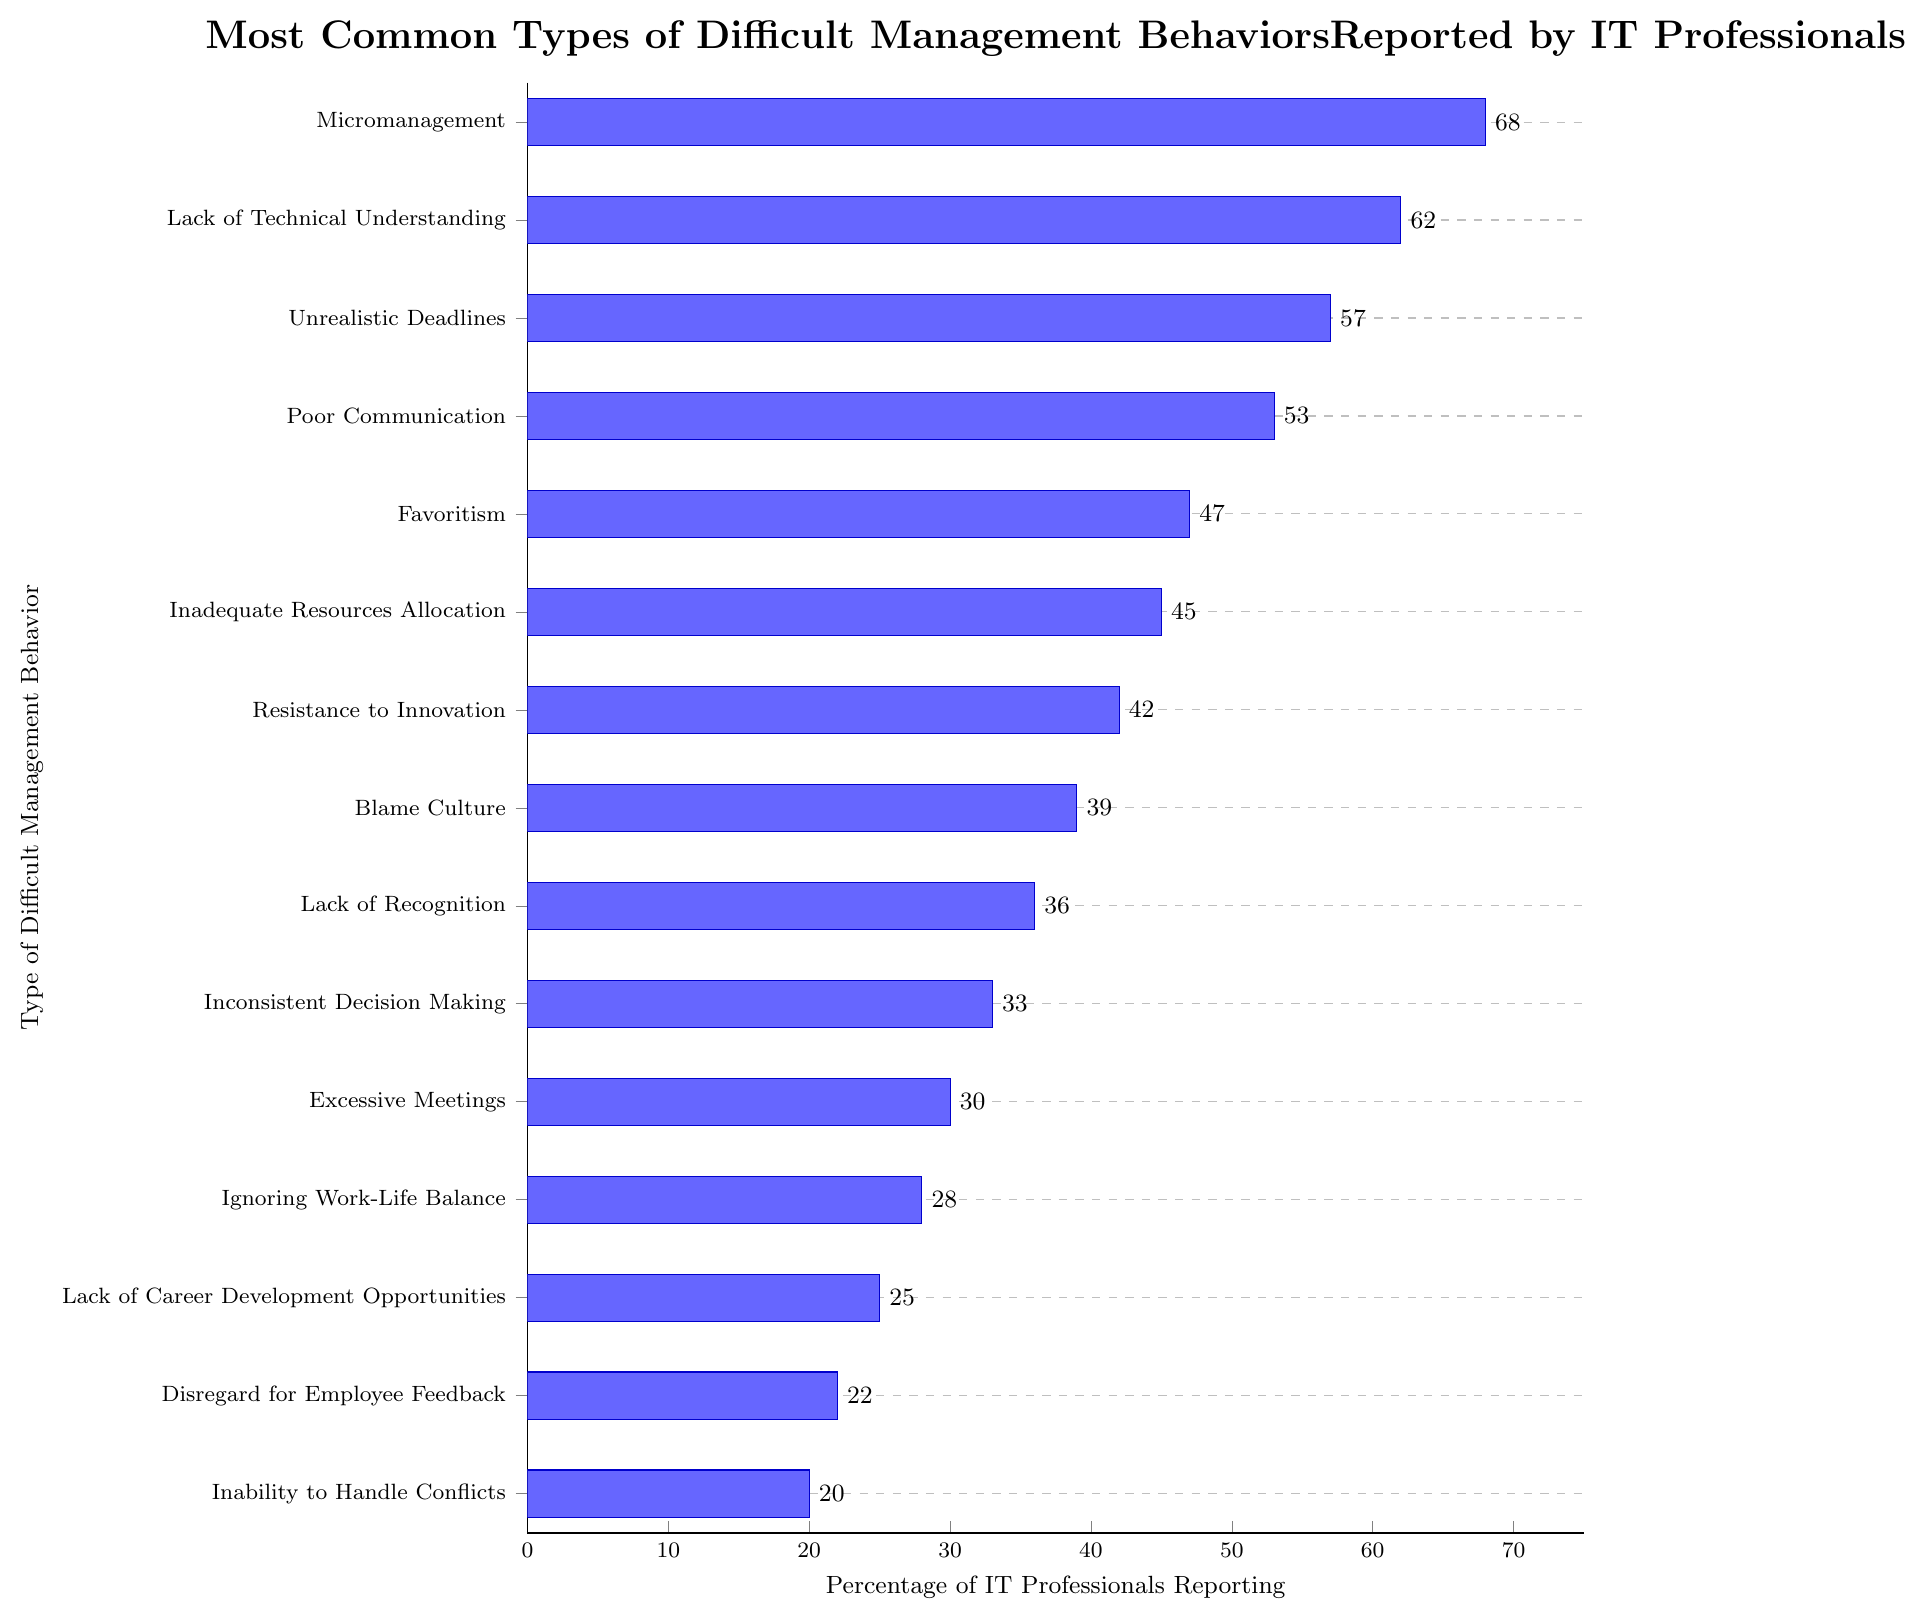What percentage of IT professionals reported micromanagement? Look at the bar corresponding to "Micromanagement" and find the value at the edge of the bar on the x-axis.
Answer: 68 Which type of difficult management behavior is reported the least by IT professionals? Identify the shortest bar on the chart and check its label on the y-axis.
Answer: Inability to Handle Conflicts How much more common is micromanagement compared to ignoring work-life balance? Find the percentage for both "Micromanagement" and "Ignoring Work-Life Balance," then calculate the difference (68 - 28).
Answer: 40 Which behaviors are reported by more than 50% of IT professionals? Identify the bars that extend beyond the 50% mark on the x-axis and list their corresponding behaviors.
Answer: Micromanagement, Lack of Technical Understanding, Unrealistic Deadlines, Poor Communication What is the average percentage of IT professionals reporting the top 3 most common difficult management behaviors? Calculate the average by summing the percentages of the top 3 behaviors (68 for Micromanagement, 62 for Lack of Technical Understanding, and 57 for Unrealistic Deadlines) and then dividing by 3. (68 + 62 + 57)/3 = 187/3 = 62.33
Answer: 62.33 Is favoritism reported more or less often than resistance to innovation? Compare the lengths of the bars for "Favoritism" and "Resistance to Innovation" and note which is longer.
Answer: More often What are the three least common difficult management behaviors reported by IT professionals? List the labels of the three shortest bars in the chart.
Answer: Inability to Handle Conflicts, Disregard for Employee Feedback, Lack of Career Development Opportunities What percentage of IT professionals reported behaviors related to communication issues (Poor Communication, Excessive Meetings)? Sum the percentages of "Poor Communication" and "Excessive Meetings" (53 + 30) to find the total.
Answer: 83 How much more common is poor communication than inconsistent decision making? Find the difference between the percentages of "Poor Communication" and "Inconsistent Decision Making" (53 - 33).
Answer: 20 Which type of behavior, inadequate resource allocation or lack of career development opportunities, is reported by more IT professionals? Compare the lengths of the bars for "Inadequate Resources Allocation" and "Lack of Career Development Opportunities" to determine which is longer.
Answer: Inadequate Resources Allocation 